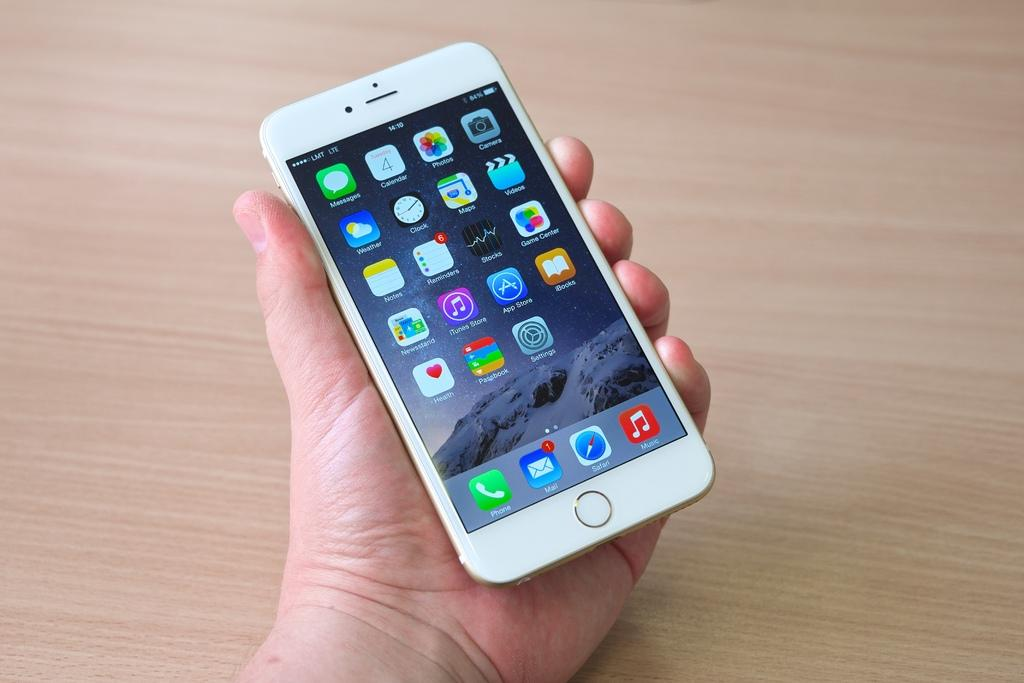<image>
Provide a brief description of the given image. A hand holds an Iphone that has many apps on it, including Safari, Music, and Photos. 